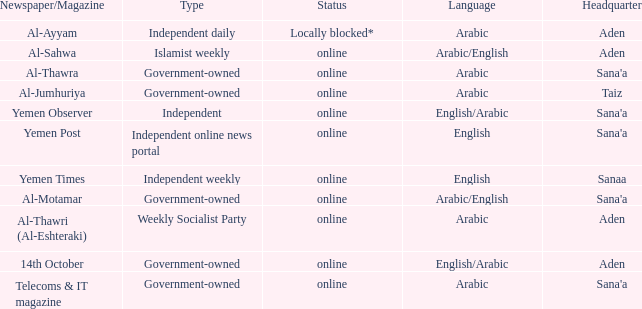What is Headquarter, when Type is Government-Owned, and when Newspaper/Magazine is Al-Jumhuriya? Taiz. 